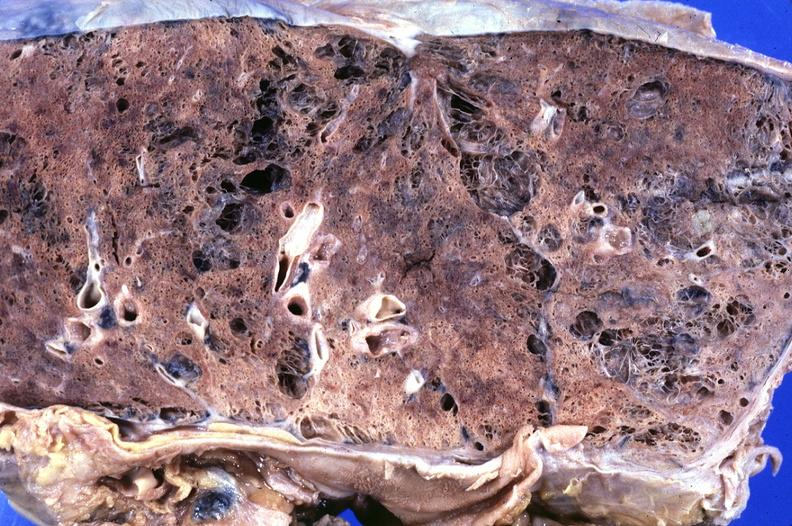s respiratory present?
Answer the question using a single word or phrase. Yes 